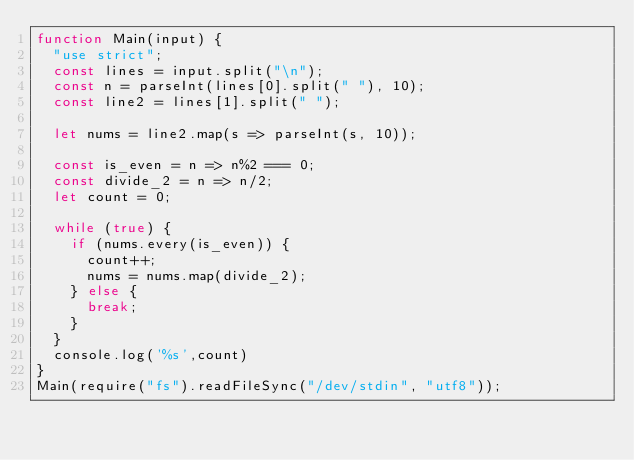Convert code to text. <code><loc_0><loc_0><loc_500><loc_500><_JavaScript_>function Main(input) {
  "use strict";
	const lines = input.split("\n");
	const n = parseInt(lines[0].split(" "), 10);
	const line2 = lines[1].split(" ");

  let nums = line2.map(s => parseInt(s, 10));

  const is_even = n => n%2 === 0;
  const divide_2 = n => n/2;
  let count = 0;

  while (true) {
    if (nums.every(is_even)) {
      count++;
      nums = nums.map(divide_2);
    } else {
      break;
    }
  }
	console.log('%s',count)
}
Main(require("fs").readFileSync("/dev/stdin", "utf8"));
</code> 